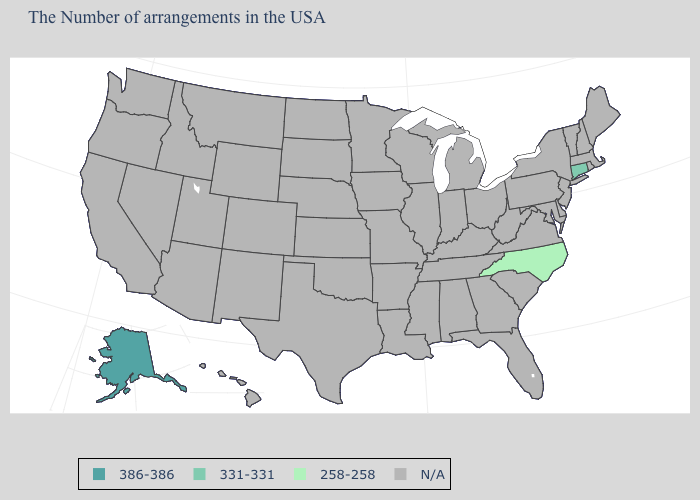Which states have the highest value in the USA?
Be succinct. Alaska. Which states have the highest value in the USA?
Keep it brief. Alaska. What is the highest value in the USA?
Answer briefly. 386-386. What is the value of Colorado?
Keep it brief. N/A. Does the first symbol in the legend represent the smallest category?
Keep it brief. No. Which states have the highest value in the USA?
Give a very brief answer. Alaska. What is the highest value in the West ?
Be succinct. 386-386. Which states have the lowest value in the South?
Write a very short answer. North Carolina. Name the states that have a value in the range 258-258?
Concise answer only. North Carolina. 